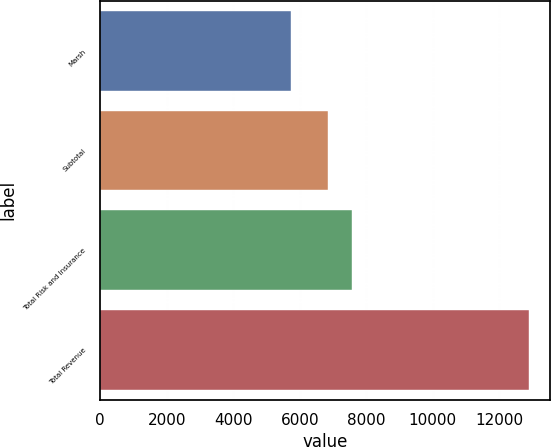Convert chart to OTSL. <chart><loc_0><loc_0><loc_500><loc_500><bar_chart><fcel>Marsh<fcel>Subtotal<fcel>Total Risk and Insurance<fcel>Total Revenue<nl><fcel>5727<fcel>6848<fcel>7564.6<fcel>12893<nl></chart> 